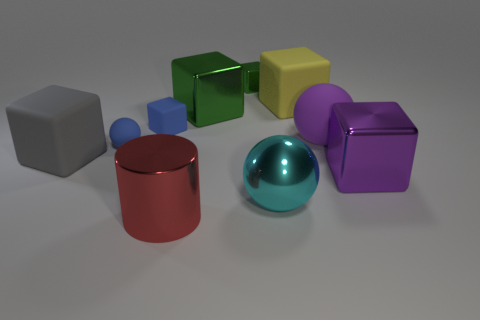Subtract 3 cubes. How many cubes are left? 3 Subtract all green cubes. How many cubes are left? 4 Subtract all small matte blocks. How many blocks are left? 5 Subtract all gray blocks. Subtract all blue cylinders. How many blocks are left? 5 Subtract all cylinders. How many objects are left? 9 Add 4 tiny metallic cubes. How many tiny metallic cubes are left? 5 Add 8 blue rubber things. How many blue rubber things exist? 10 Subtract 0 red spheres. How many objects are left? 10 Subtract all big yellow rubber things. Subtract all cyan metal things. How many objects are left? 8 